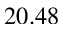<formula> <loc_0><loc_0><loc_500><loc_500>2 0 . 4 8</formula> 